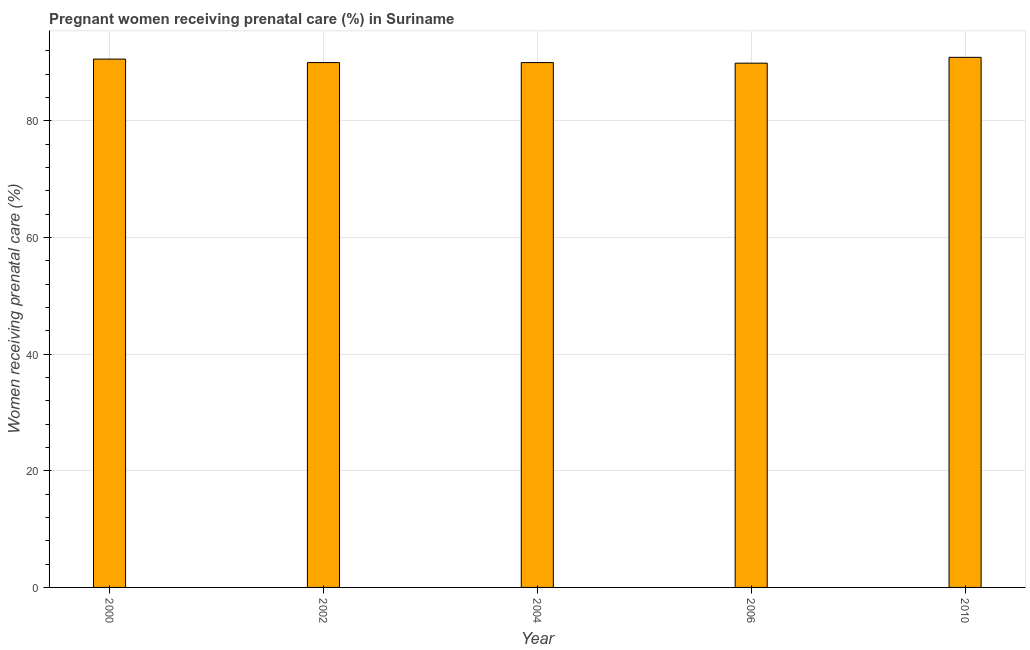Does the graph contain any zero values?
Give a very brief answer. No. Does the graph contain grids?
Your answer should be compact. Yes. What is the title of the graph?
Provide a short and direct response. Pregnant women receiving prenatal care (%) in Suriname. What is the label or title of the X-axis?
Your answer should be compact. Year. What is the label or title of the Y-axis?
Make the answer very short. Women receiving prenatal care (%). What is the percentage of pregnant women receiving prenatal care in 2010?
Offer a terse response. 90.9. Across all years, what is the maximum percentage of pregnant women receiving prenatal care?
Offer a very short reply. 90.9. Across all years, what is the minimum percentage of pregnant women receiving prenatal care?
Make the answer very short. 89.9. In which year was the percentage of pregnant women receiving prenatal care minimum?
Your response must be concise. 2006. What is the sum of the percentage of pregnant women receiving prenatal care?
Ensure brevity in your answer.  451.4. What is the average percentage of pregnant women receiving prenatal care per year?
Make the answer very short. 90.28. What is the median percentage of pregnant women receiving prenatal care?
Keep it short and to the point. 90. Do a majority of the years between 2002 and 2010 (inclusive) have percentage of pregnant women receiving prenatal care greater than 4 %?
Offer a terse response. Yes. What is the ratio of the percentage of pregnant women receiving prenatal care in 2004 to that in 2010?
Provide a short and direct response. 0.99. Is the percentage of pregnant women receiving prenatal care in 2000 less than that in 2010?
Your response must be concise. Yes. What is the difference between the highest and the second highest percentage of pregnant women receiving prenatal care?
Your response must be concise. 0.3. How many bars are there?
Your answer should be very brief. 5. Are all the bars in the graph horizontal?
Ensure brevity in your answer.  No. What is the Women receiving prenatal care (%) of 2000?
Your answer should be compact. 90.6. What is the Women receiving prenatal care (%) in 2006?
Your answer should be very brief. 89.9. What is the Women receiving prenatal care (%) of 2010?
Make the answer very short. 90.9. What is the difference between the Women receiving prenatal care (%) in 2000 and 2002?
Your answer should be very brief. 0.6. What is the difference between the Women receiving prenatal care (%) in 2002 and 2004?
Your answer should be very brief. 0. What is the difference between the Women receiving prenatal care (%) in 2002 and 2006?
Provide a succinct answer. 0.1. What is the difference between the Women receiving prenatal care (%) in 2002 and 2010?
Your answer should be very brief. -0.9. What is the difference between the Women receiving prenatal care (%) in 2004 and 2010?
Keep it short and to the point. -0.9. What is the ratio of the Women receiving prenatal care (%) in 2000 to that in 2004?
Provide a short and direct response. 1.01. What is the ratio of the Women receiving prenatal care (%) in 2000 to that in 2006?
Your response must be concise. 1.01. What is the ratio of the Women receiving prenatal care (%) in 2000 to that in 2010?
Provide a short and direct response. 1. What is the ratio of the Women receiving prenatal care (%) in 2004 to that in 2006?
Provide a short and direct response. 1. What is the ratio of the Women receiving prenatal care (%) in 2004 to that in 2010?
Give a very brief answer. 0.99. What is the ratio of the Women receiving prenatal care (%) in 2006 to that in 2010?
Offer a terse response. 0.99. 